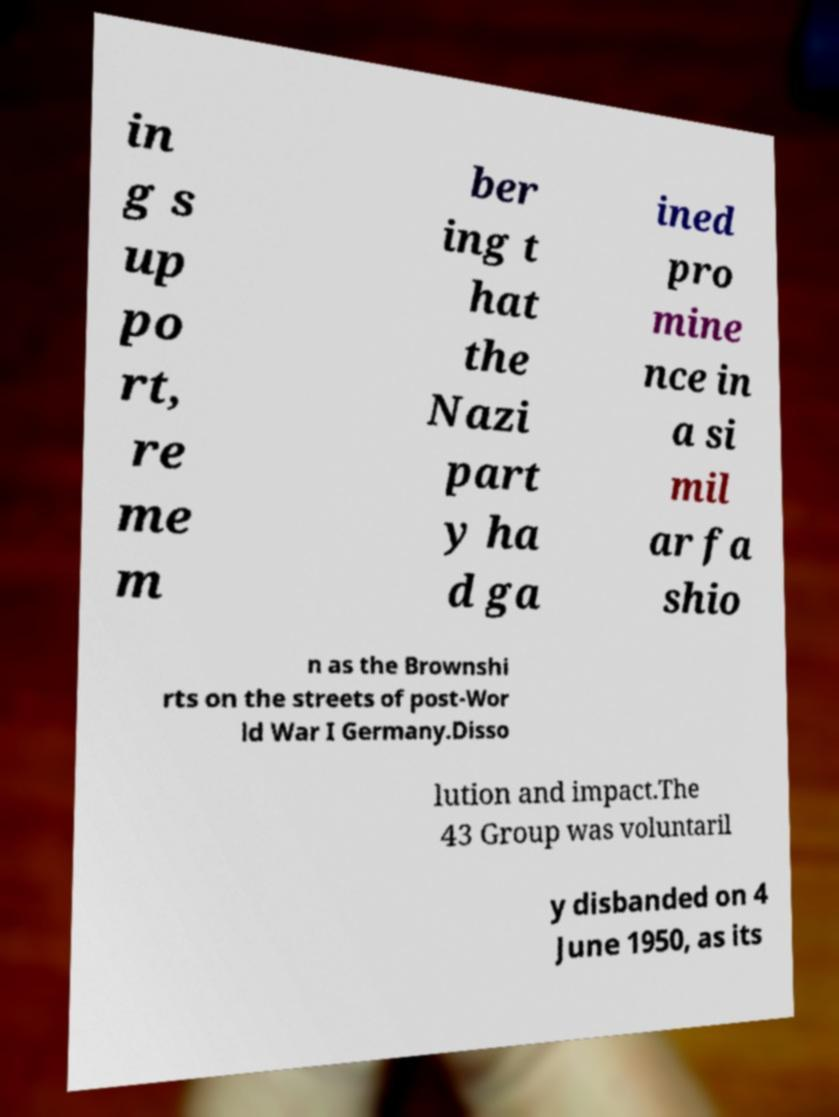There's text embedded in this image that I need extracted. Can you transcribe it verbatim? in g s up po rt, re me m ber ing t hat the Nazi part y ha d ga ined pro mine nce in a si mil ar fa shio n as the Brownshi rts on the streets of post-Wor ld War I Germany.Disso lution and impact.The 43 Group was voluntaril y disbanded on 4 June 1950, as its 